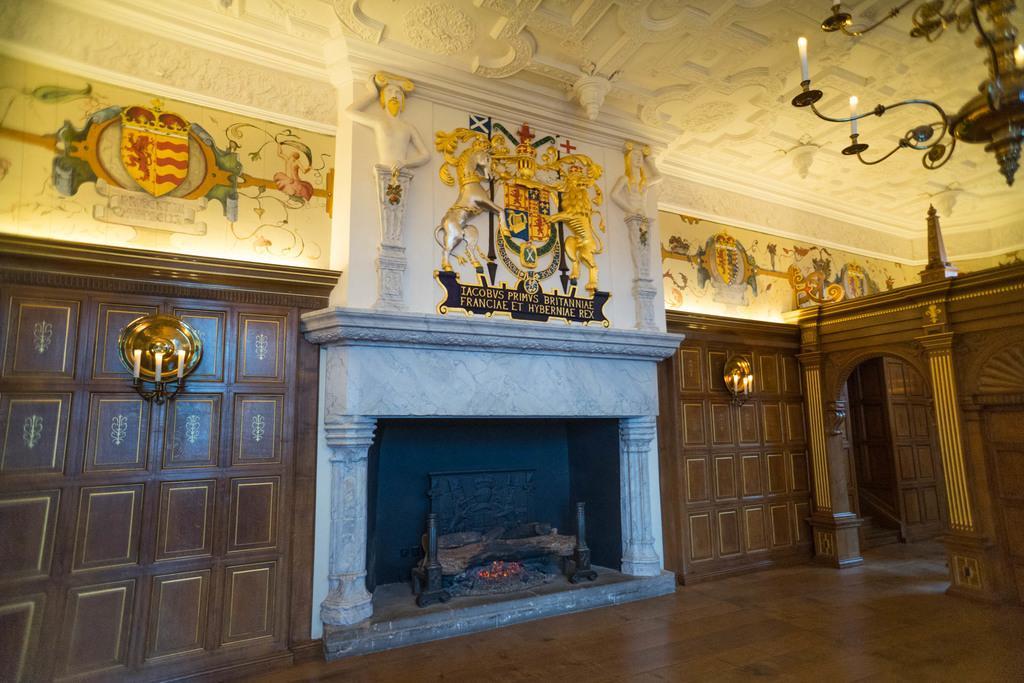Please provide a concise description of this image. In this image I can see doors in brown color, in front I can see a fireplace. Background I can see few statues, candles and the wall is in white color. 